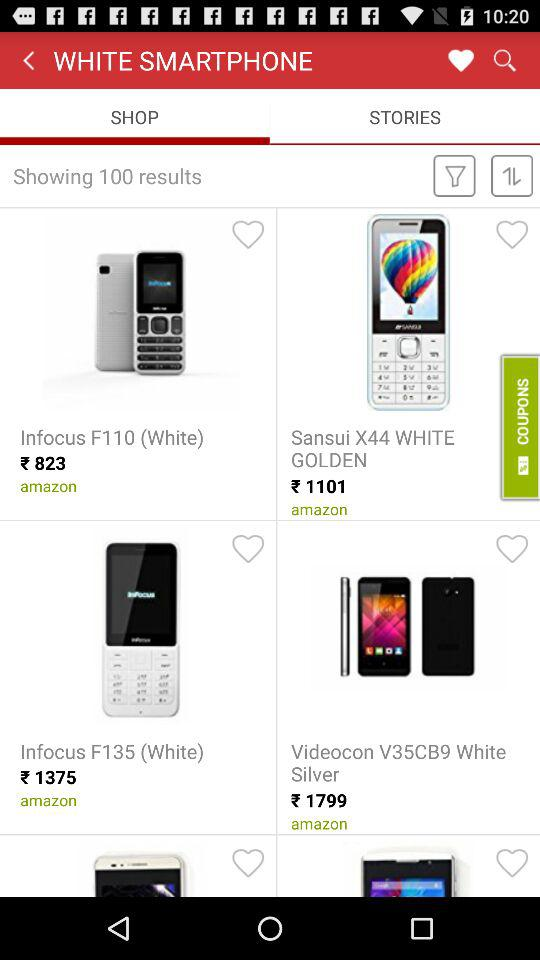What is the name of the application?
When the provided information is insufficient, respond with <no answer>. <no answer> 